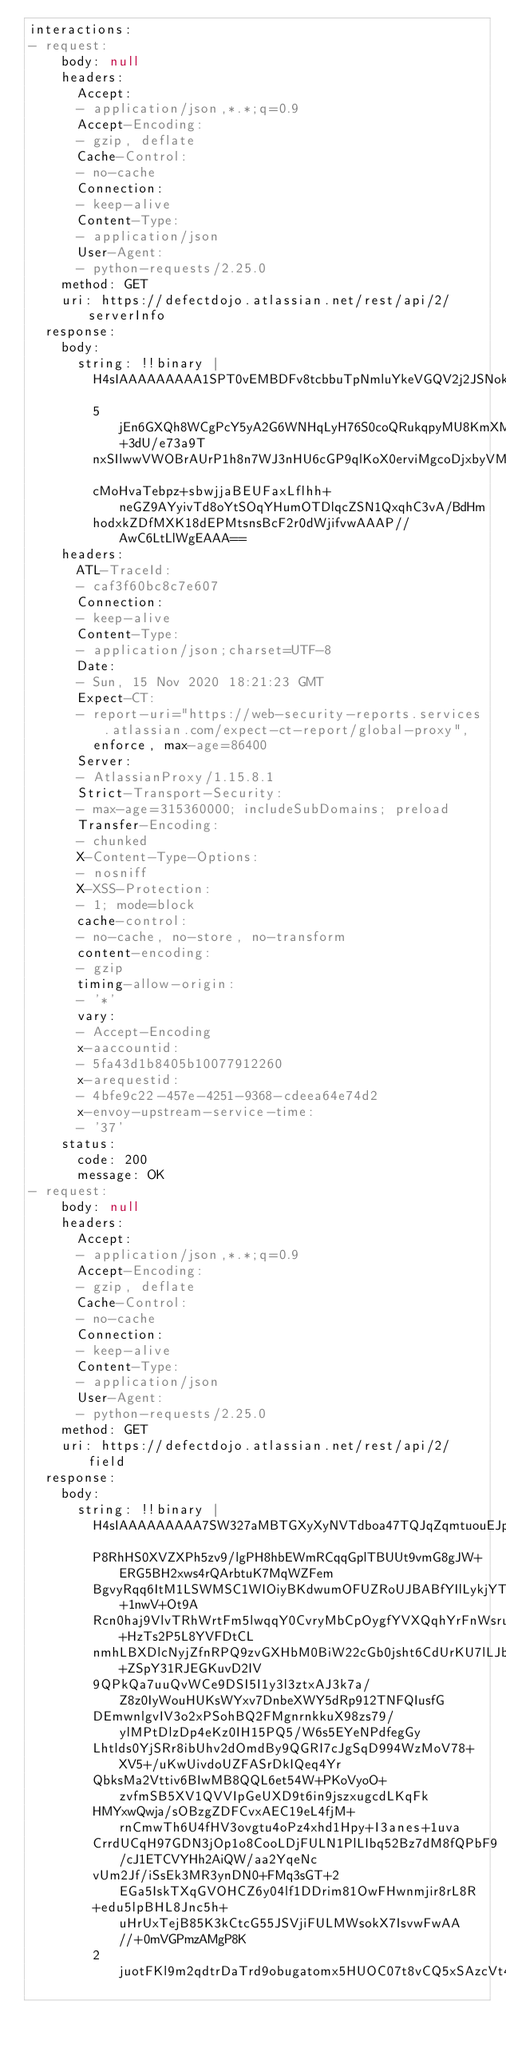<code> <loc_0><loc_0><loc_500><loc_500><_YAML_>interactions:
- request:
    body: null
    headers:
      Accept:
      - application/json,*.*;q=0.9
      Accept-Encoding:
      - gzip, deflate
      Cache-Control:
      - no-cache
      Connection:
      - keep-alive
      Content-Type:
      - application/json
      User-Agent:
      - python-requests/2.25.0
    method: GET
    uri: https://defectdojo.atlassian.net/rest/api/2/serverInfo
  response:
    body:
      string: !!binary |
        H4sIAAAAAAAAA1SPT0vEMBDFv8tcbbuTpNmluYkeVGQV2j2JSNokWEmT0qTCsux3N8HFP8zl8eb3
        5jEn6GXQh8WCgPcY5yA2G6WNHqLyH76S0coQRukqpyMU8KmXMHqXYIJIKqywbPfXz+3dU/e73a9T
        nxSIlwwVWOBrAUrP1h8n7WJ3nHU6cGP9qlKoX0erviMgcoDjxbyVMYMUKZaElIR1WAuGgqVixCtM
        cMoHvaTebpz+sbwjjaBEUFaxLflhh+neGZ9AYyivTd8oYtSOqYHumOTDlqcZSN1QxqhC3vA/BdHm
        hodxkZDfMXK18dEPMtsnsBcF2r0dWjifvwAAAP//AwC6LtLlWgEAAA==
    headers:
      ATL-TraceId:
      - caf3f60bc8c7e607
      Connection:
      - keep-alive
      Content-Type:
      - application/json;charset=UTF-8
      Date:
      - Sun, 15 Nov 2020 18:21:23 GMT
      Expect-CT:
      - report-uri="https://web-security-reports.services.atlassian.com/expect-ct-report/global-proxy",
        enforce, max-age=86400
      Server:
      - AtlassianProxy/1.15.8.1
      Strict-Transport-Security:
      - max-age=315360000; includeSubDomains; preload
      Transfer-Encoding:
      - chunked
      X-Content-Type-Options:
      - nosniff
      X-XSS-Protection:
      - 1; mode=block
      cache-control:
      - no-cache, no-store, no-transform
      content-encoding:
      - gzip
      timing-allow-origin:
      - '*'
      vary:
      - Accept-Encoding
      x-aaccountid:
      - 5fa43d1b8405b10077912260
      x-arequestid:
      - 4bfe9c22-457e-4251-9368-cdeea64e74d2
      x-envoy-upstream-service-time:
      - '37'
    status:
      code: 200
      message: OK
- request:
    body: null
    headers:
      Accept:
      - application/json,*.*;q=0.9
      Accept-Encoding:
      - gzip, deflate
      Cache-Control:
      - no-cache
      Connection:
      - keep-alive
      Content-Type:
      - application/json
      User-Agent:
      - python-requests/2.25.0
    method: GET
    uri: https://defectdojo.atlassian.net/rest/api/2/field
  response:
    body:
      string: !!binary |
        H4sIAAAAAAAAA7SW327aMBTGXyXyNVTdboa47TQJqZqmtuouEJpMOAS3iYNshxZVfZq9z55px7Hj
        P8RhHS0XVZXPh5zv9/lgPH8hbEWmRCqqGplTBUUt9vmG8gJW+ERG5BH2xws4rQArbtuK7MqWZFem
        BgvyRqq6ItM1LSWMSC1WIOiyBKdwumOFUZRoUJBABfYIlLykjYTv2EqS6dza6XrZVl+1nwV+Ot9A
        Rcn0haj9VlvTRhWrtFm5lwqqY0CvryMbCpOygfYVXQqhYrFnWsrujDZMaij+HzTs2P5L8YVFDtCL
        nmhLBXDlcNyjZfnRPQ9zvGXHbM0BiW22cGb0jsht6CdUrKU7lLJbq53Dlu+ZSpY31RJEGKuvD2IV
        9QPkQa7uuQvWCe9DSI5I1y3l3ztxAJ3k7a/Z8z0IyWouHUKsWYxv7DnbeXWY5dRp912TNFQIusfG
        DEmwnlgvIV3o2xPSohBQ2FMgnrnkkuX98zs79/ylMPtDlzDp4eKz0IH15PQ5/W6s5EYeNPdfegGy
        Lhtlds0YjSRr8ibUhv2dOmdBy9QGRI7cJgSqD994WzMoV78+XV5+/uKwUivdoUZFASrDkIQeq4Yr
        QbksMa2Vttiv6BIwMB8QQL6et54W+PKoVyoO+zvfmSB5XV1QVVIpGeUXD9t6in9jszxugcdLKqFk
        HMYxwQwja/sOBzgZDFCvxAEC19eL4fjM+rnCmwTh6U4fHV3ovgtu4oPz4xhd1Hpy+I3anes+1uva
        CrrdUCqH97GDN3jOp1o8CooLDjFULN1PlLIbq52Bz7dM8fQPbF9/cJ1ETCVYHh2AiQW/aa2YqeNc
        vUm2Jf/iSsEk3MR3ynDN0+FMq3sGT+2EGa5IskTXqGVOHCZ6y04lf1DDrim81OwFHwnmjir8rL8R
        +edu5lpBHL8Jnc5h+uHrUxTejB85K3kCtcG55JSVjiFULMWsokX7IsvwFwAA//+0mVGPmzAMgP8K
        2juotFKl9m2qdtrDaTrd9obugatomx5HUOC07t8vCQ5xSAzcVt4gDtj5bGI73HMNNu0fRaG2594Q</code> 